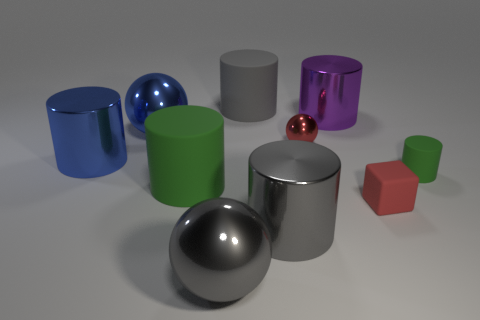The red thing that is behind the tiny object that is in front of the green cylinder that is on the left side of the gray metallic sphere is made of what material?
Keep it short and to the point. Metal. Do the red rubber object and the red metal object have the same shape?
Provide a succinct answer. No. What number of matte objects are large green cylinders or brown objects?
Ensure brevity in your answer.  1. What number of big objects are there?
Offer a very short reply. 7. There is another metallic sphere that is the same size as the blue sphere; what color is it?
Offer a very short reply. Gray. Is the red rubber block the same size as the gray metal cylinder?
Ensure brevity in your answer.  No. What is the shape of the tiny metallic thing that is the same color as the tiny cube?
Provide a short and direct response. Sphere. Do the rubber cube and the metal cylinder to the left of the blue sphere have the same size?
Give a very brief answer. No. The cylinder that is both in front of the big purple thing and to the right of the red metal ball is what color?
Your answer should be compact. Green. Are there more tiny green rubber cylinders in front of the tiny green rubber cylinder than big metal cylinders that are behind the large purple thing?
Your answer should be very brief. No. 